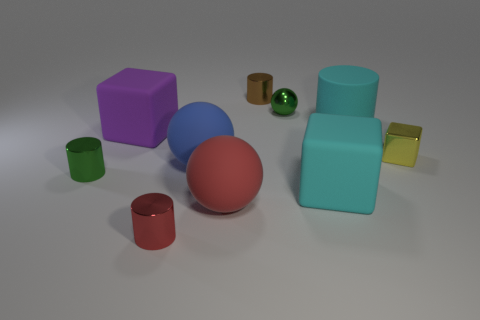Subtract 1 cylinders. How many cylinders are left? 3 Subtract all rubber cylinders. How many cylinders are left? 3 Subtract all green cylinders. How many cylinders are left? 3 Subtract all balls. How many objects are left? 7 Subtract all brown metallic objects. Subtract all blue matte balls. How many objects are left? 8 Add 8 rubber cubes. How many rubber cubes are left? 10 Add 6 large cyan rubber objects. How many large cyan rubber objects exist? 8 Subtract 0 green cubes. How many objects are left? 10 Subtract all yellow spheres. Subtract all purple cylinders. How many spheres are left? 3 